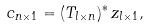<formula> <loc_0><loc_0><loc_500><loc_500>c _ { n \times 1 } = ( T _ { l \times n } ) ^ { * } \, z _ { l \times 1 } ,</formula> 